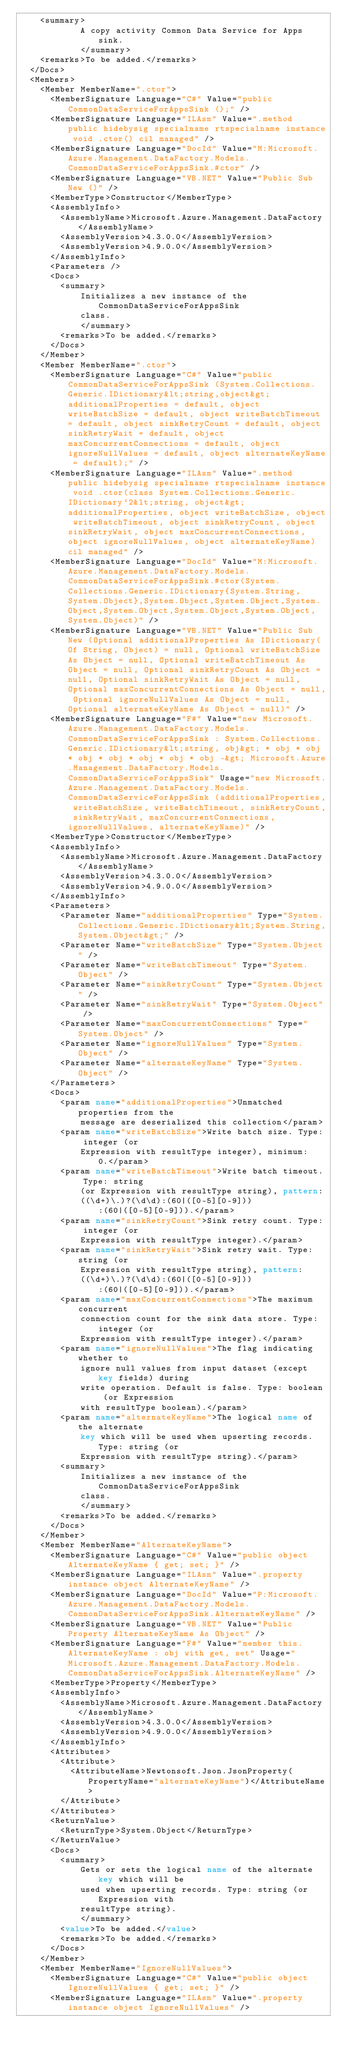<code> <loc_0><loc_0><loc_500><loc_500><_XML_>    <summary>
            A copy activity Common Data Service for Apps sink.
            </summary>
    <remarks>To be added.</remarks>
  </Docs>
  <Members>
    <Member MemberName=".ctor">
      <MemberSignature Language="C#" Value="public CommonDataServiceForAppsSink ();" />
      <MemberSignature Language="ILAsm" Value=".method public hidebysig specialname rtspecialname instance void .ctor() cil managed" />
      <MemberSignature Language="DocId" Value="M:Microsoft.Azure.Management.DataFactory.Models.CommonDataServiceForAppsSink.#ctor" />
      <MemberSignature Language="VB.NET" Value="Public Sub New ()" />
      <MemberType>Constructor</MemberType>
      <AssemblyInfo>
        <AssemblyName>Microsoft.Azure.Management.DataFactory</AssemblyName>
        <AssemblyVersion>4.3.0.0</AssemblyVersion>
        <AssemblyVersion>4.9.0.0</AssemblyVersion>
      </AssemblyInfo>
      <Parameters />
      <Docs>
        <summary>
            Initializes a new instance of the CommonDataServiceForAppsSink
            class.
            </summary>
        <remarks>To be added.</remarks>
      </Docs>
    </Member>
    <Member MemberName=".ctor">
      <MemberSignature Language="C#" Value="public CommonDataServiceForAppsSink (System.Collections.Generic.IDictionary&lt;string,object&gt; additionalProperties = default, object writeBatchSize = default, object writeBatchTimeout = default, object sinkRetryCount = default, object sinkRetryWait = default, object maxConcurrentConnections = default, object ignoreNullValues = default, object alternateKeyName = default);" />
      <MemberSignature Language="ILAsm" Value=".method public hidebysig specialname rtspecialname instance void .ctor(class System.Collections.Generic.IDictionary`2&lt;string, object&gt; additionalProperties, object writeBatchSize, object writeBatchTimeout, object sinkRetryCount, object sinkRetryWait, object maxConcurrentConnections, object ignoreNullValues, object alternateKeyName) cil managed" />
      <MemberSignature Language="DocId" Value="M:Microsoft.Azure.Management.DataFactory.Models.CommonDataServiceForAppsSink.#ctor(System.Collections.Generic.IDictionary{System.String,System.Object},System.Object,System.Object,System.Object,System.Object,System.Object,System.Object,System.Object)" />
      <MemberSignature Language="VB.NET" Value="Public Sub New (Optional additionalProperties As IDictionary(Of String, Object) = null, Optional writeBatchSize As Object = null, Optional writeBatchTimeout As Object = null, Optional sinkRetryCount As Object = null, Optional sinkRetryWait As Object = null, Optional maxConcurrentConnections As Object = null, Optional ignoreNullValues As Object = null, Optional alternateKeyName As Object = null)" />
      <MemberSignature Language="F#" Value="new Microsoft.Azure.Management.DataFactory.Models.CommonDataServiceForAppsSink : System.Collections.Generic.IDictionary&lt;string, obj&gt; * obj * obj * obj * obj * obj * obj * obj -&gt; Microsoft.Azure.Management.DataFactory.Models.CommonDataServiceForAppsSink" Usage="new Microsoft.Azure.Management.DataFactory.Models.CommonDataServiceForAppsSink (additionalProperties, writeBatchSize, writeBatchTimeout, sinkRetryCount, sinkRetryWait, maxConcurrentConnections, ignoreNullValues, alternateKeyName)" />
      <MemberType>Constructor</MemberType>
      <AssemblyInfo>
        <AssemblyName>Microsoft.Azure.Management.DataFactory</AssemblyName>
        <AssemblyVersion>4.3.0.0</AssemblyVersion>
        <AssemblyVersion>4.9.0.0</AssemblyVersion>
      </AssemblyInfo>
      <Parameters>
        <Parameter Name="additionalProperties" Type="System.Collections.Generic.IDictionary&lt;System.String,System.Object&gt;" />
        <Parameter Name="writeBatchSize" Type="System.Object" />
        <Parameter Name="writeBatchTimeout" Type="System.Object" />
        <Parameter Name="sinkRetryCount" Type="System.Object" />
        <Parameter Name="sinkRetryWait" Type="System.Object" />
        <Parameter Name="maxConcurrentConnections" Type="System.Object" />
        <Parameter Name="ignoreNullValues" Type="System.Object" />
        <Parameter Name="alternateKeyName" Type="System.Object" />
      </Parameters>
      <Docs>
        <param name="additionalProperties">Unmatched properties from the
            message are deserialized this collection</param>
        <param name="writeBatchSize">Write batch size. Type: integer (or
            Expression with resultType integer), minimum: 0.</param>
        <param name="writeBatchTimeout">Write batch timeout. Type: string
            (or Expression with resultType string), pattern:
            ((\d+)\.)?(\d\d):(60|([0-5][0-9])):(60|([0-5][0-9])).</param>
        <param name="sinkRetryCount">Sink retry count. Type: integer (or
            Expression with resultType integer).</param>
        <param name="sinkRetryWait">Sink retry wait. Type: string (or
            Expression with resultType string), pattern:
            ((\d+)\.)?(\d\d):(60|([0-5][0-9])):(60|([0-5][0-9])).</param>
        <param name="maxConcurrentConnections">The maximum concurrent
            connection count for the sink data store. Type: integer (or
            Expression with resultType integer).</param>
        <param name="ignoreNullValues">The flag indicating whether to
            ignore null values from input dataset (except key fields) during
            write operation. Default is false. Type: boolean (or Expression
            with resultType boolean).</param>
        <param name="alternateKeyName">The logical name of the alternate
            key which will be used when upserting records. Type: string (or
            Expression with resultType string).</param>
        <summary>
            Initializes a new instance of the CommonDataServiceForAppsSink
            class.
            </summary>
        <remarks>To be added.</remarks>
      </Docs>
    </Member>
    <Member MemberName="AlternateKeyName">
      <MemberSignature Language="C#" Value="public object AlternateKeyName { get; set; }" />
      <MemberSignature Language="ILAsm" Value=".property instance object AlternateKeyName" />
      <MemberSignature Language="DocId" Value="P:Microsoft.Azure.Management.DataFactory.Models.CommonDataServiceForAppsSink.AlternateKeyName" />
      <MemberSignature Language="VB.NET" Value="Public Property AlternateKeyName As Object" />
      <MemberSignature Language="F#" Value="member this.AlternateKeyName : obj with get, set" Usage="Microsoft.Azure.Management.DataFactory.Models.CommonDataServiceForAppsSink.AlternateKeyName" />
      <MemberType>Property</MemberType>
      <AssemblyInfo>
        <AssemblyName>Microsoft.Azure.Management.DataFactory</AssemblyName>
        <AssemblyVersion>4.3.0.0</AssemblyVersion>
        <AssemblyVersion>4.9.0.0</AssemblyVersion>
      </AssemblyInfo>
      <Attributes>
        <Attribute>
          <AttributeName>Newtonsoft.Json.JsonProperty(PropertyName="alternateKeyName")</AttributeName>
        </Attribute>
      </Attributes>
      <ReturnValue>
        <ReturnType>System.Object</ReturnType>
      </ReturnValue>
      <Docs>
        <summary>
            Gets or sets the logical name of the alternate key which will be
            used when upserting records. Type: string (or Expression with
            resultType string).
            </summary>
        <value>To be added.</value>
        <remarks>To be added.</remarks>
      </Docs>
    </Member>
    <Member MemberName="IgnoreNullValues">
      <MemberSignature Language="C#" Value="public object IgnoreNullValues { get; set; }" />
      <MemberSignature Language="ILAsm" Value=".property instance object IgnoreNullValues" /></code> 